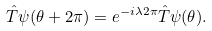Convert formula to latex. <formula><loc_0><loc_0><loc_500><loc_500>\hat { T } \psi ( \theta + 2 \pi ) = e ^ { - i \lambda 2 \pi } \hat { T } \psi ( \theta ) .</formula> 